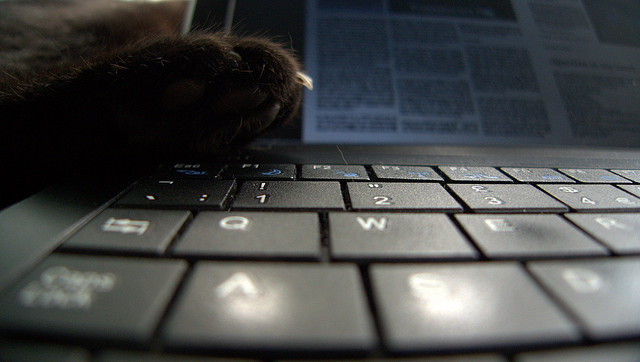Identify the text contained in this image. 0 W 7 2 3 